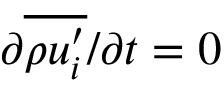<formula> <loc_0><loc_0><loc_500><loc_500>{ \partial \overline { { \rho u _ { i } ^ { \prime } } } } / { \partial t } = 0</formula> 